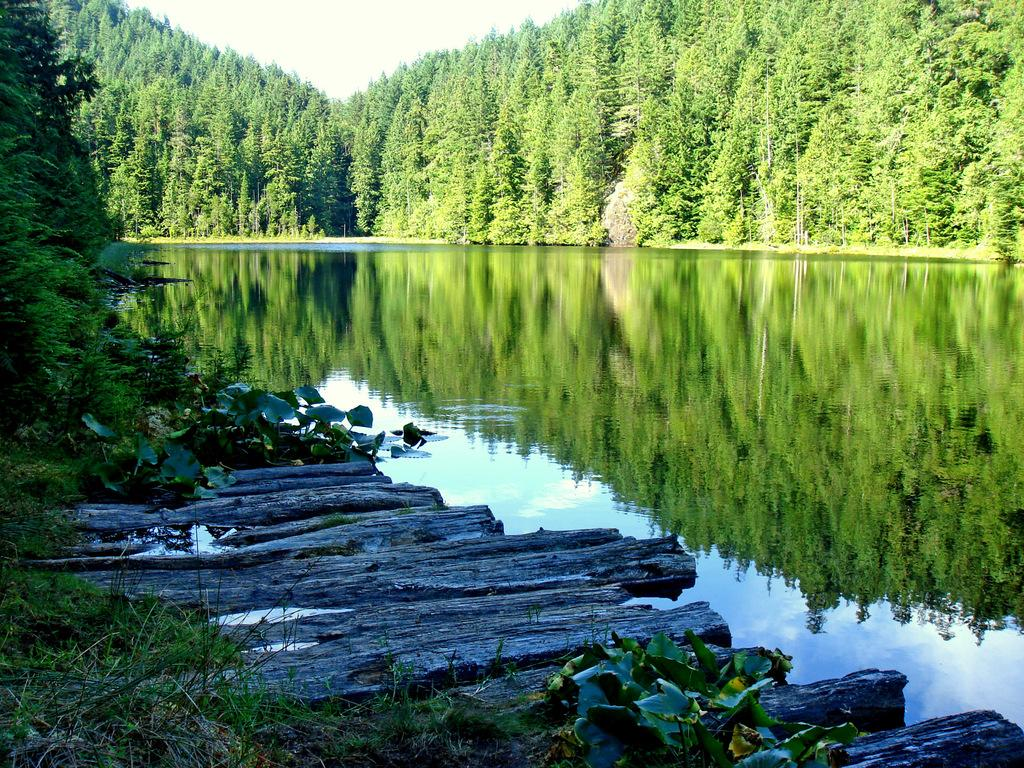What type of natural body of water is present in the image? There is a lake in the picture. What type of vegetation can be seen in the image? There are trees and plants in the picture. What is the condition of the sky in the image? The sky is clear in the picture. What type of comb is being used to groom the animals in the image? There are no animals or combs present in the image; it features a lake, trees, plants, and a clear sky. What type of pain can be seen on the person's face in the image? There are no people or expressions of pain visible in the image. 